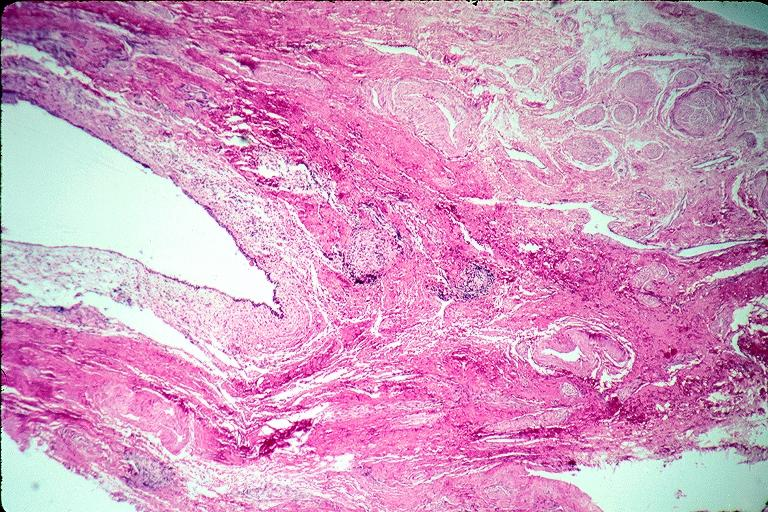what is present?
Answer the question using a single word or phrase. Oral 